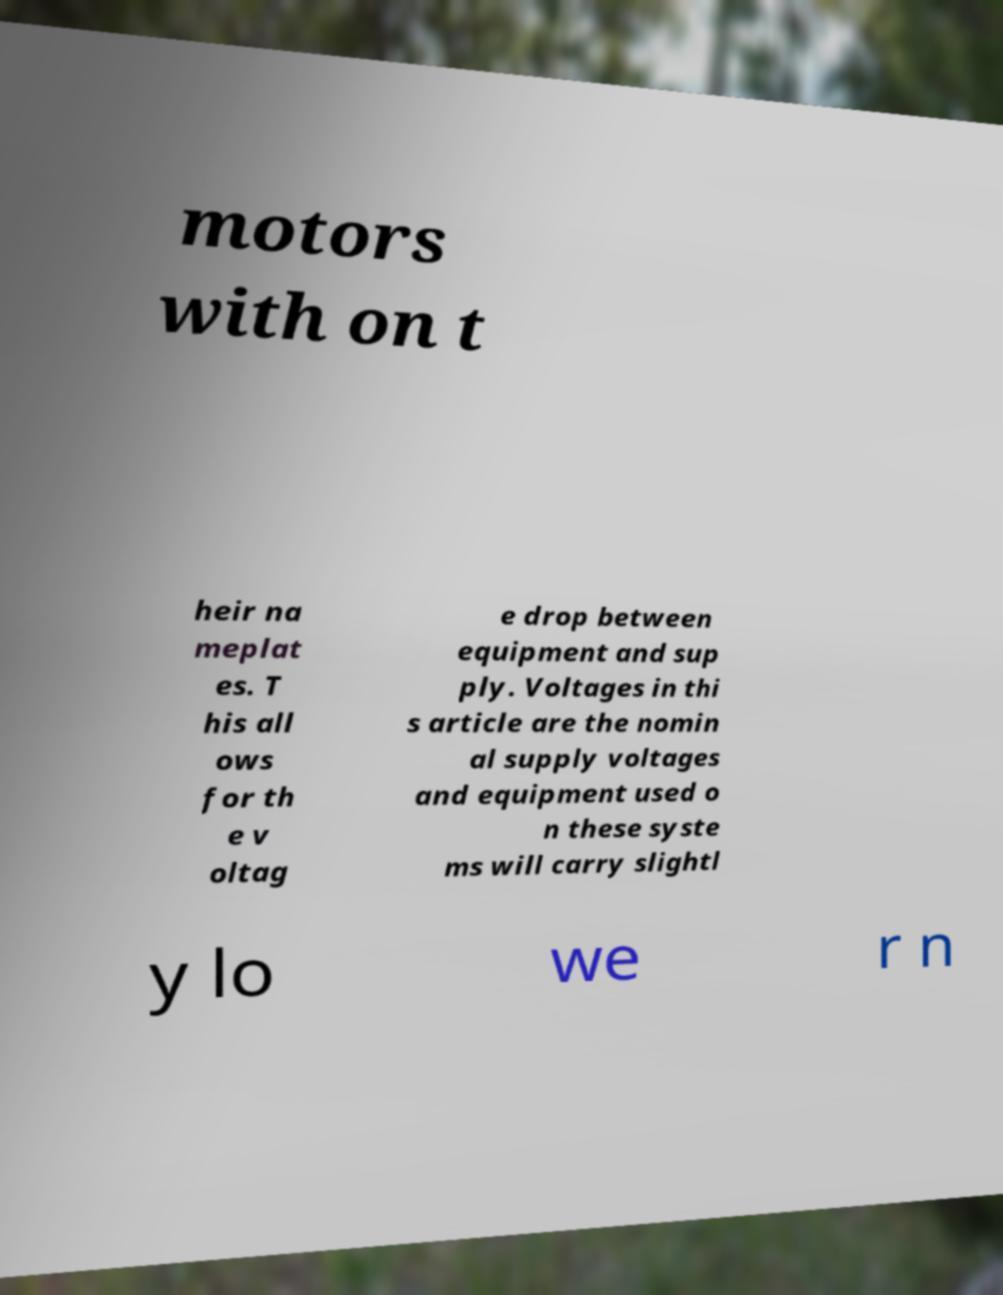There's text embedded in this image that I need extracted. Can you transcribe it verbatim? motors with on t heir na meplat es. T his all ows for th e v oltag e drop between equipment and sup ply. Voltages in thi s article are the nomin al supply voltages and equipment used o n these syste ms will carry slightl y lo we r n 